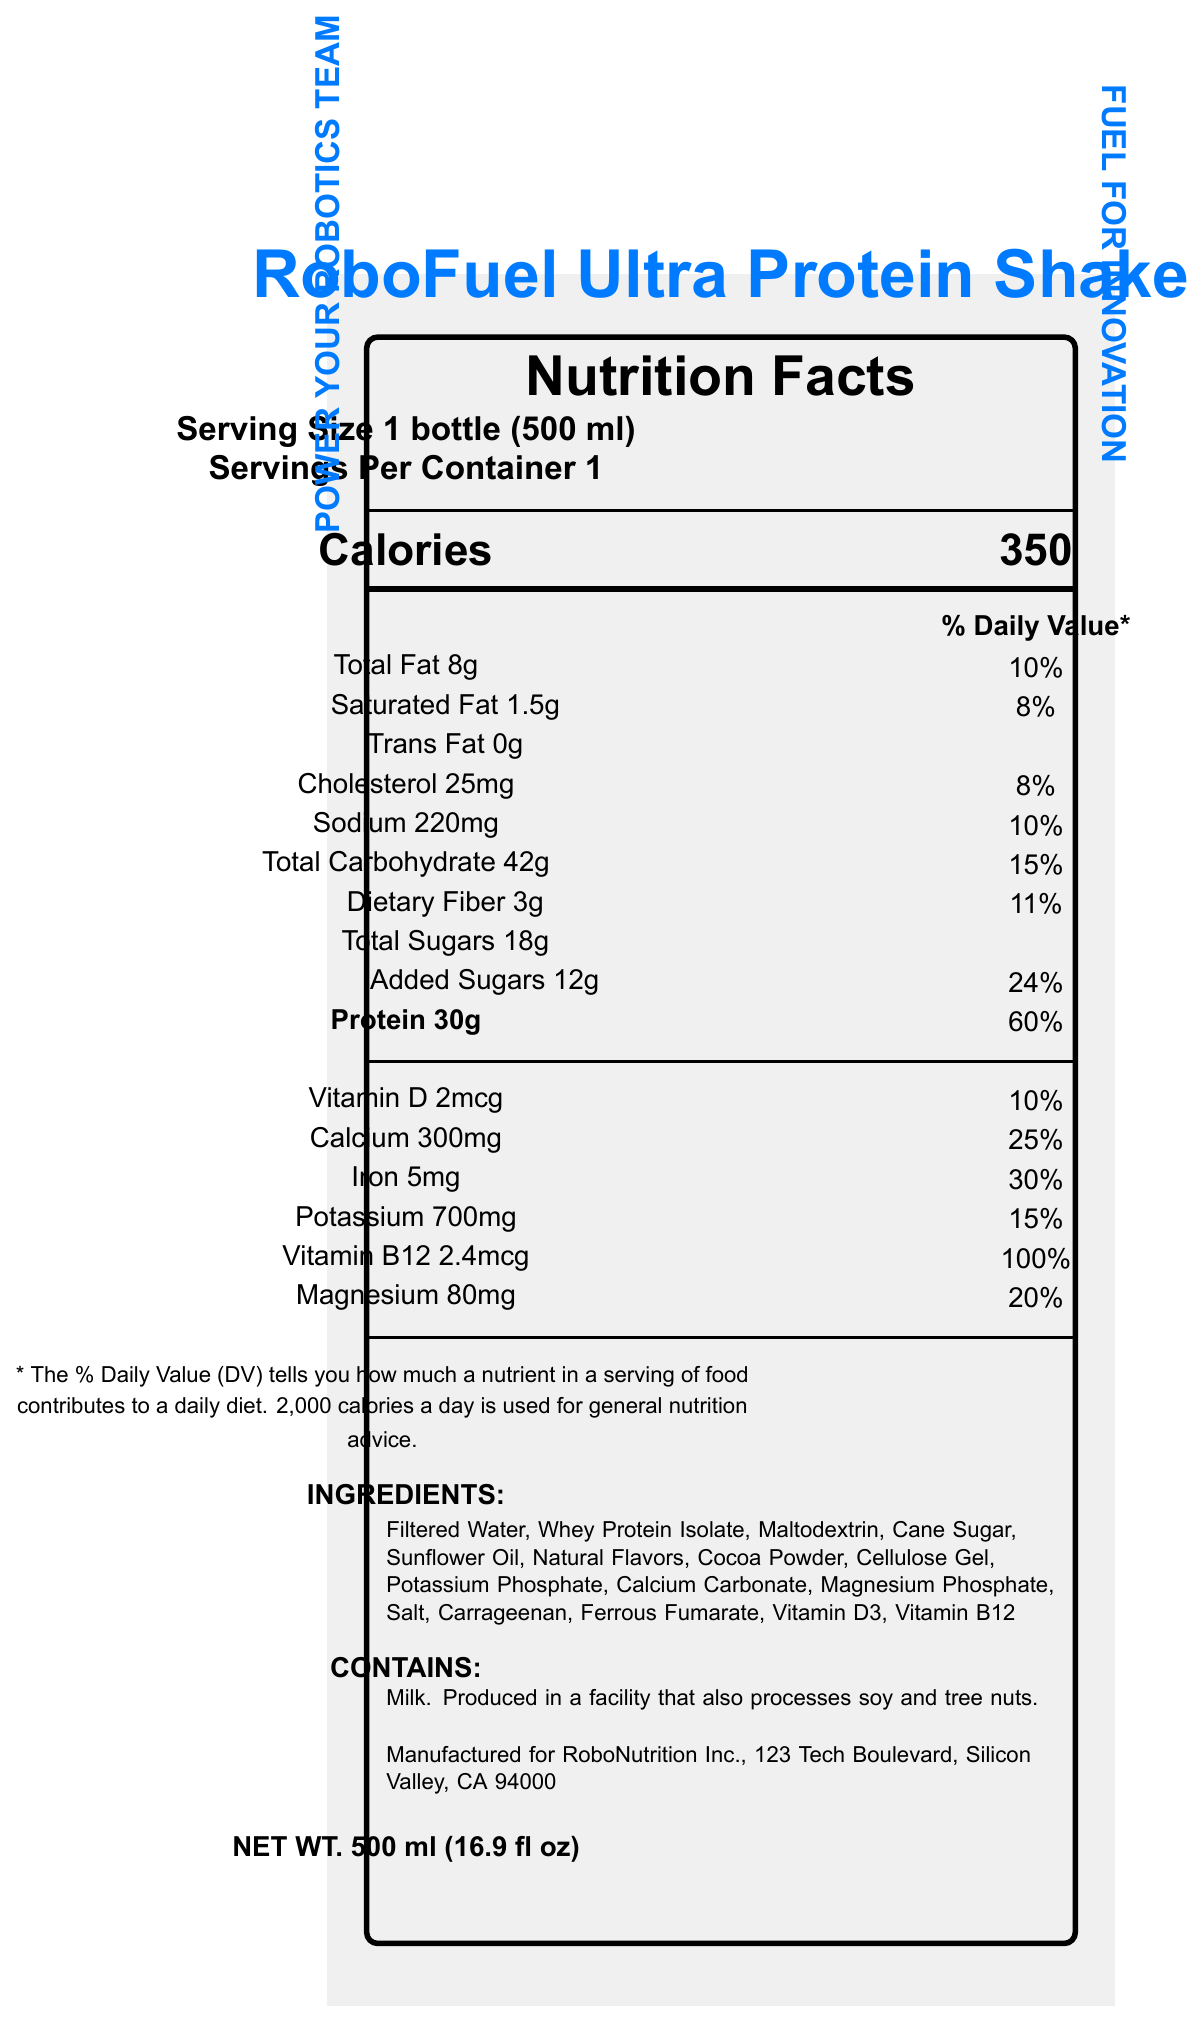what is the name of the product? The name of the product is shown at the top of the document in a bold and large font.
Answer: RoboFuel Ultra Protein Shake how many servings are there in one container? The document states that there is 1 serving per container under the Serving size section.
Answer: 1 how many calories are in one serving? The calorie count is displayed prominently under the Calories section.
Answer: 350 what is the amount of protein in one serving and its daily value percentage? The Protein section lists 30g and the daily value percentage as 60%.
Answer: 30g, 60% what are the main ingredients? list at least three. The ingredients section shows Filtered Water, Whey Protein Isolate, and Maltodextrin among the first listed.
Answer: Filtered Water, Whey Protein Isolate, Maltodextrin what is the percentage of daily value for added sugars? A. 20% B. 24% C. 30% D. 10% The document lists the percentage for added sugars as 24%.
Answer: B which claim statement is NOT mentioned in the document? 1. Supports muscle recovery 2. Enhances brain function 3. Improves heart health 4. Provides energy during long sessions The statements mentioned are related to muscle recovery, cognitive function, and providing energy, but not heart health.
Answer: 3 is there any trans fat in the product? The Trans Fat section lists 0g.
Answer: No does the product contain any allergens? The allergen information states that it contains milk and is produced in a facility that processes soy and tree nuts.
Answer: Yes what is the main idea of the document? The document provides detailed nutrition facts, ingredients, and claim statements highlighting its benefits for mental focus, physical endurance, muscle recovery, and energy provision.
Answer: RoboFuel Ultra Protein Shake is a high-energy protein shake designed for robotics team members, providing nutrients to support physical and mental performance. how many grams of dietary fiber are in one serving? The Dietary Fiber section lists 3g.
Answer: 3g what is the address of the manufacturer? The manufacturer information provides this address.
Answer: 123 Tech Boulevard, Silicon Valley, CA 94000 what is the percent daily value of potassium? The Potassium section lists the daily value percentage as 15%.
Answer: 15% how much vitamin B12 is in one serving? The Vitamin B12 section lists 2.4mcg.
Answer: 2.4mcg can the vitamin content of the product be considered high? The document provides specific vitamin content but does not compare it to standard values for determining high vitamin content.
Answer: Not enough information what is the serving size in milliliters? The serving size is listed as 1 bottle (500 ml).
Answer: 500 ml what is the net weight of the product in fluid ounces? The net weight section lists 500 ml, which is also shown as 16.9 fl oz.
Answer: 16.9 fl oz which vitamin has the highest percent daily value in the shake? A. Vitamin D B. Calcium C. Iron D. Vitamin B12 Vitamin B12 has the highest percent daily value at 100%, compared to others listed below 100%.
Answer: D is the product specifically formulated for enhancing cognitive function? One of the claim statements mentions it is enhanced with vitamins and minerals to support cognitive function.
Answer: Yes 